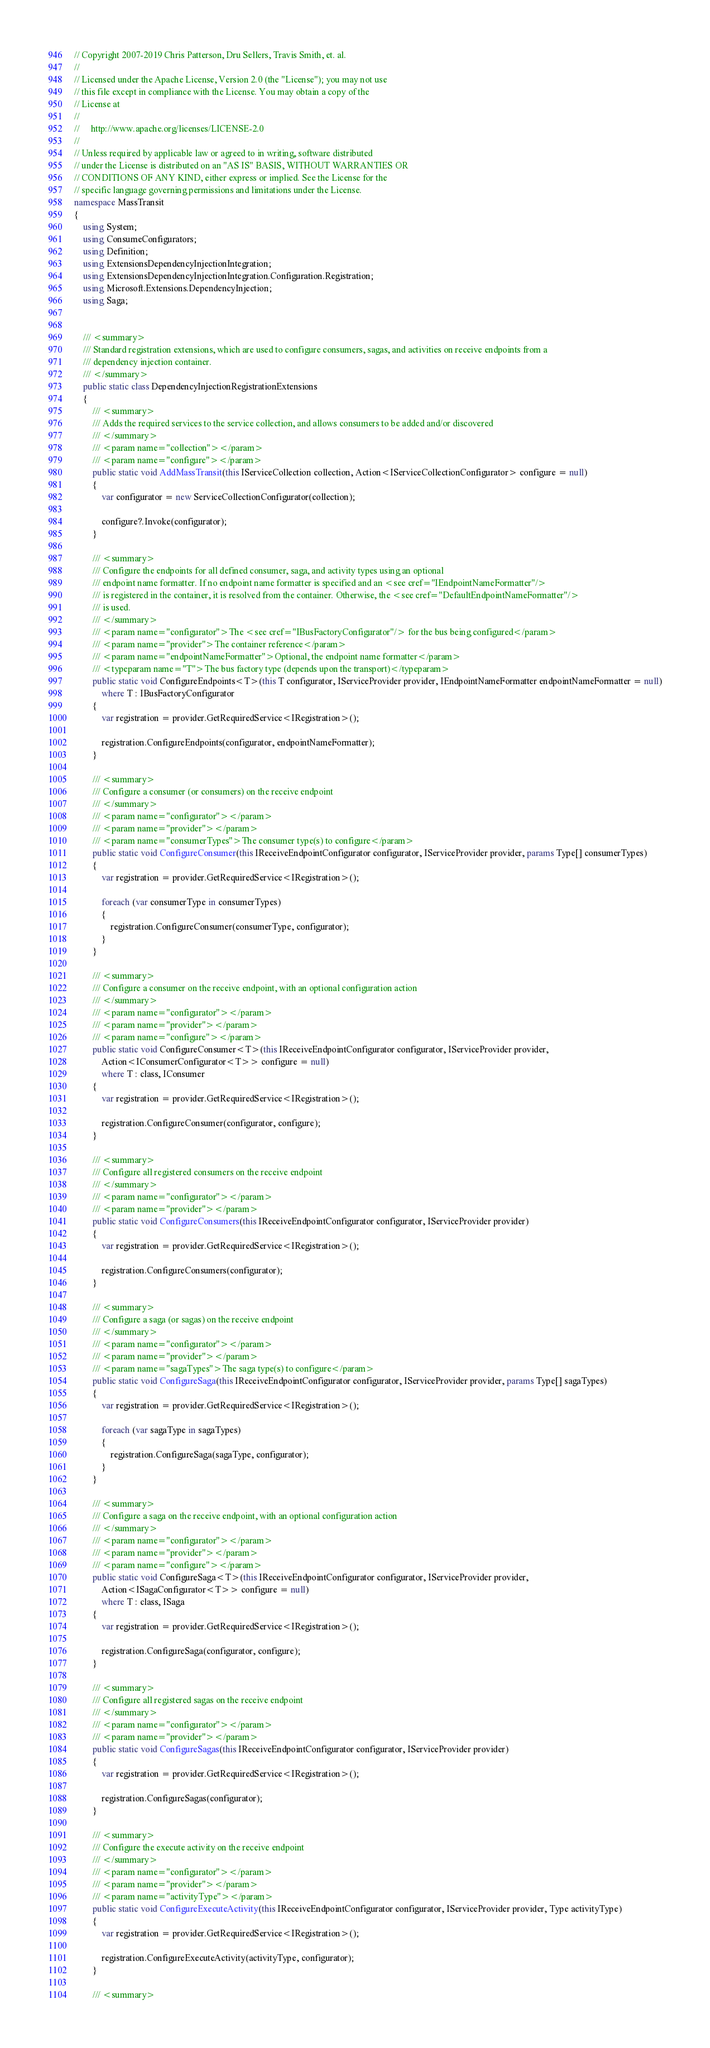Convert code to text. <code><loc_0><loc_0><loc_500><loc_500><_C#_>// Copyright 2007-2019 Chris Patterson, Dru Sellers, Travis Smith, et. al.
//
// Licensed under the Apache License, Version 2.0 (the "License"); you may not use
// this file except in compliance with the License. You may obtain a copy of the
// License at
//
//     http://www.apache.org/licenses/LICENSE-2.0
//
// Unless required by applicable law or agreed to in writing, software distributed
// under the License is distributed on an "AS IS" BASIS, WITHOUT WARRANTIES OR
// CONDITIONS OF ANY KIND, either express or implied. See the License for the
// specific language governing permissions and limitations under the License.
namespace MassTransit
{
    using System;
    using ConsumeConfigurators;
    using Definition;
    using ExtensionsDependencyInjectionIntegration;
    using ExtensionsDependencyInjectionIntegration.Configuration.Registration;
    using Microsoft.Extensions.DependencyInjection;
    using Saga;


    /// <summary>
    /// Standard registration extensions, which are used to configure consumers, sagas, and activities on receive endpoints from a
    /// dependency injection container.
    /// </summary>
    public static class DependencyInjectionRegistrationExtensions
    {
        /// <summary>
        /// Adds the required services to the service collection, and allows consumers to be added and/or discovered
        /// </summary>
        /// <param name="collection"></param>
        /// <param name="configure"></param>
        public static void AddMassTransit(this IServiceCollection collection, Action<IServiceCollectionConfigurator> configure = null)
        {
            var configurator = new ServiceCollectionConfigurator(collection);

            configure?.Invoke(configurator);
        }

        /// <summary>
        /// Configure the endpoints for all defined consumer, saga, and activity types using an optional
        /// endpoint name formatter. If no endpoint name formatter is specified and an <see cref="IEndpointNameFormatter"/>
        /// is registered in the container, it is resolved from the container. Otherwise, the <see cref="DefaultEndpointNameFormatter"/>
        /// is used.
        /// </summary>
        /// <param name="configurator">The <see cref="IBusFactoryConfigurator"/> for the bus being configured</param>
        /// <param name="provider">The container reference</param>
        /// <param name="endpointNameFormatter">Optional, the endpoint name formatter</param>
        /// <typeparam name="T">The bus factory type (depends upon the transport)</typeparam>
        public static void ConfigureEndpoints<T>(this T configurator, IServiceProvider provider, IEndpointNameFormatter endpointNameFormatter = null)
            where T : IBusFactoryConfigurator
        {
            var registration = provider.GetRequiredService<IRegistration>();

            registration.ConfigureEndpoints(configurator, endpointNameFormatter);
        }

        /// <summary>
        /// Configure a consumer (or consumers) on the receive endpoint
        /// </summary>
        /// <param name="configurator"></param>
        /// <param name="provider"></param>
        /// <param name="consumerTypes">The consumer type(s) to configure</param>
        public static void ConfigureConsumer(this IReceiveEndpointConfigurator configurator, IServiceProvider provider, params Type[] consumerTypes)
        {
            var registration = provider.GetRequiredService<IRegistration>();

            foreach (var consumerType in consumerTypes)
            {
                registration.ConfigureConsumer(consumerType, configurator);
            }
        }

        /// <summary>
        /// Configure a consumer on the receive endpoint, with an optional configuration action
        /// </summary>
        /// <param name="configurator"></param>
        /// <param name="provider"></param>
        /// <param name="configure"></param>
        public static void ConfigureConsumer<T>(this IReceiveEndpointConfigurator configurator, IServiceProvider provider,
            Action<IConsumerConfigurator<T>> configure = null)
            where T : class, IConsumer
        {
            var registration = provider.GetRequiredService<IRegistration>();

            registration.ConfigureConsumer(configurator, configure);
        }

        /// <summary>
        /// Configure all registered consumers on the receive endpoint
        /// </summary>
        /// <param name="configurator"></param>
        /// <param name="provider"></param>
        public static void ConfigureConsumers(this IReceiveEndpointConfigurator configurator, IServiceProvider provider)
        {
            var registration = provider.GetRequiredService<IRegistration>();

            registration.ConfigureConsumers(configurator);
        }

        /// <summary>
        /// Configure a saga (or sagas) on the receive endpoint
        /// </summary>
        /// <param name="configurator"></param>
        /// <param name="provider"></param>
        /// <param name="sagaTypes">The saga type(s) to configure</param>
        public static void ConfigureSaga(this IReceiveEndpointConfigurator configurator, IServiceProvider provider, params Type[] sagaTypes)
        {
            var registration = provider.GetRequiredService<IRegistration>();

            foreach (var sagaType in sagaTypes)
            {
                registration.ConfigureSaga(sagaType, configurator);
            }
        }

        /// <summary>
        /// Configure a saga on the receive endpoint, with an optional configuration action
        /// </summary>
        /// <param name="configurator"></param>
        /// <param name="provider"></param>
        /// <param name="configure"></param>
        public static void ConfigureSaga<T>(this IReceiveEndpointConfigurator configurator, IServiceProvider provider,
            Action<ISagaConfigurator<T>> configure = null)
            where T : class, ISaga
        {
            var registration = provider.GetRequiredService<IRegistration>();

            registration.ConfigureSaga(configurator, configure);
        }

        /// <summary>
        /// Configure all registered sagas on the receive endpoint
        /// </summary>
        /// <param name="configurator"></param>
        /// <param name="provider"></param>
        public static void ConfigureSagas(this IReceiveEndpointConfigurator configurator, IServiceProvider provider)
        {
            var registration = provider.GetRequiredService<IRegistration>();

            registration.ConfigureSagas(configurator);
        }

        /// <summary>
        /// Configure the execute activity on the receive endpoint
        /// </summary>
        /// <param name="configurator"></param>
        /// <param name="provider"></param>
        /// <param name="activityType"></param>
        public static void ConfigureExecuteActivity(this IReceiveEndpointConfigurator configurator, IServiceProvider provider, Type activityType)
        {
            var registration = provider.GetRequiredService<IRegistration>();

            registration.ConfigureExecuteActivity(activityType, configurator);
        }

        /// <summary></code> 